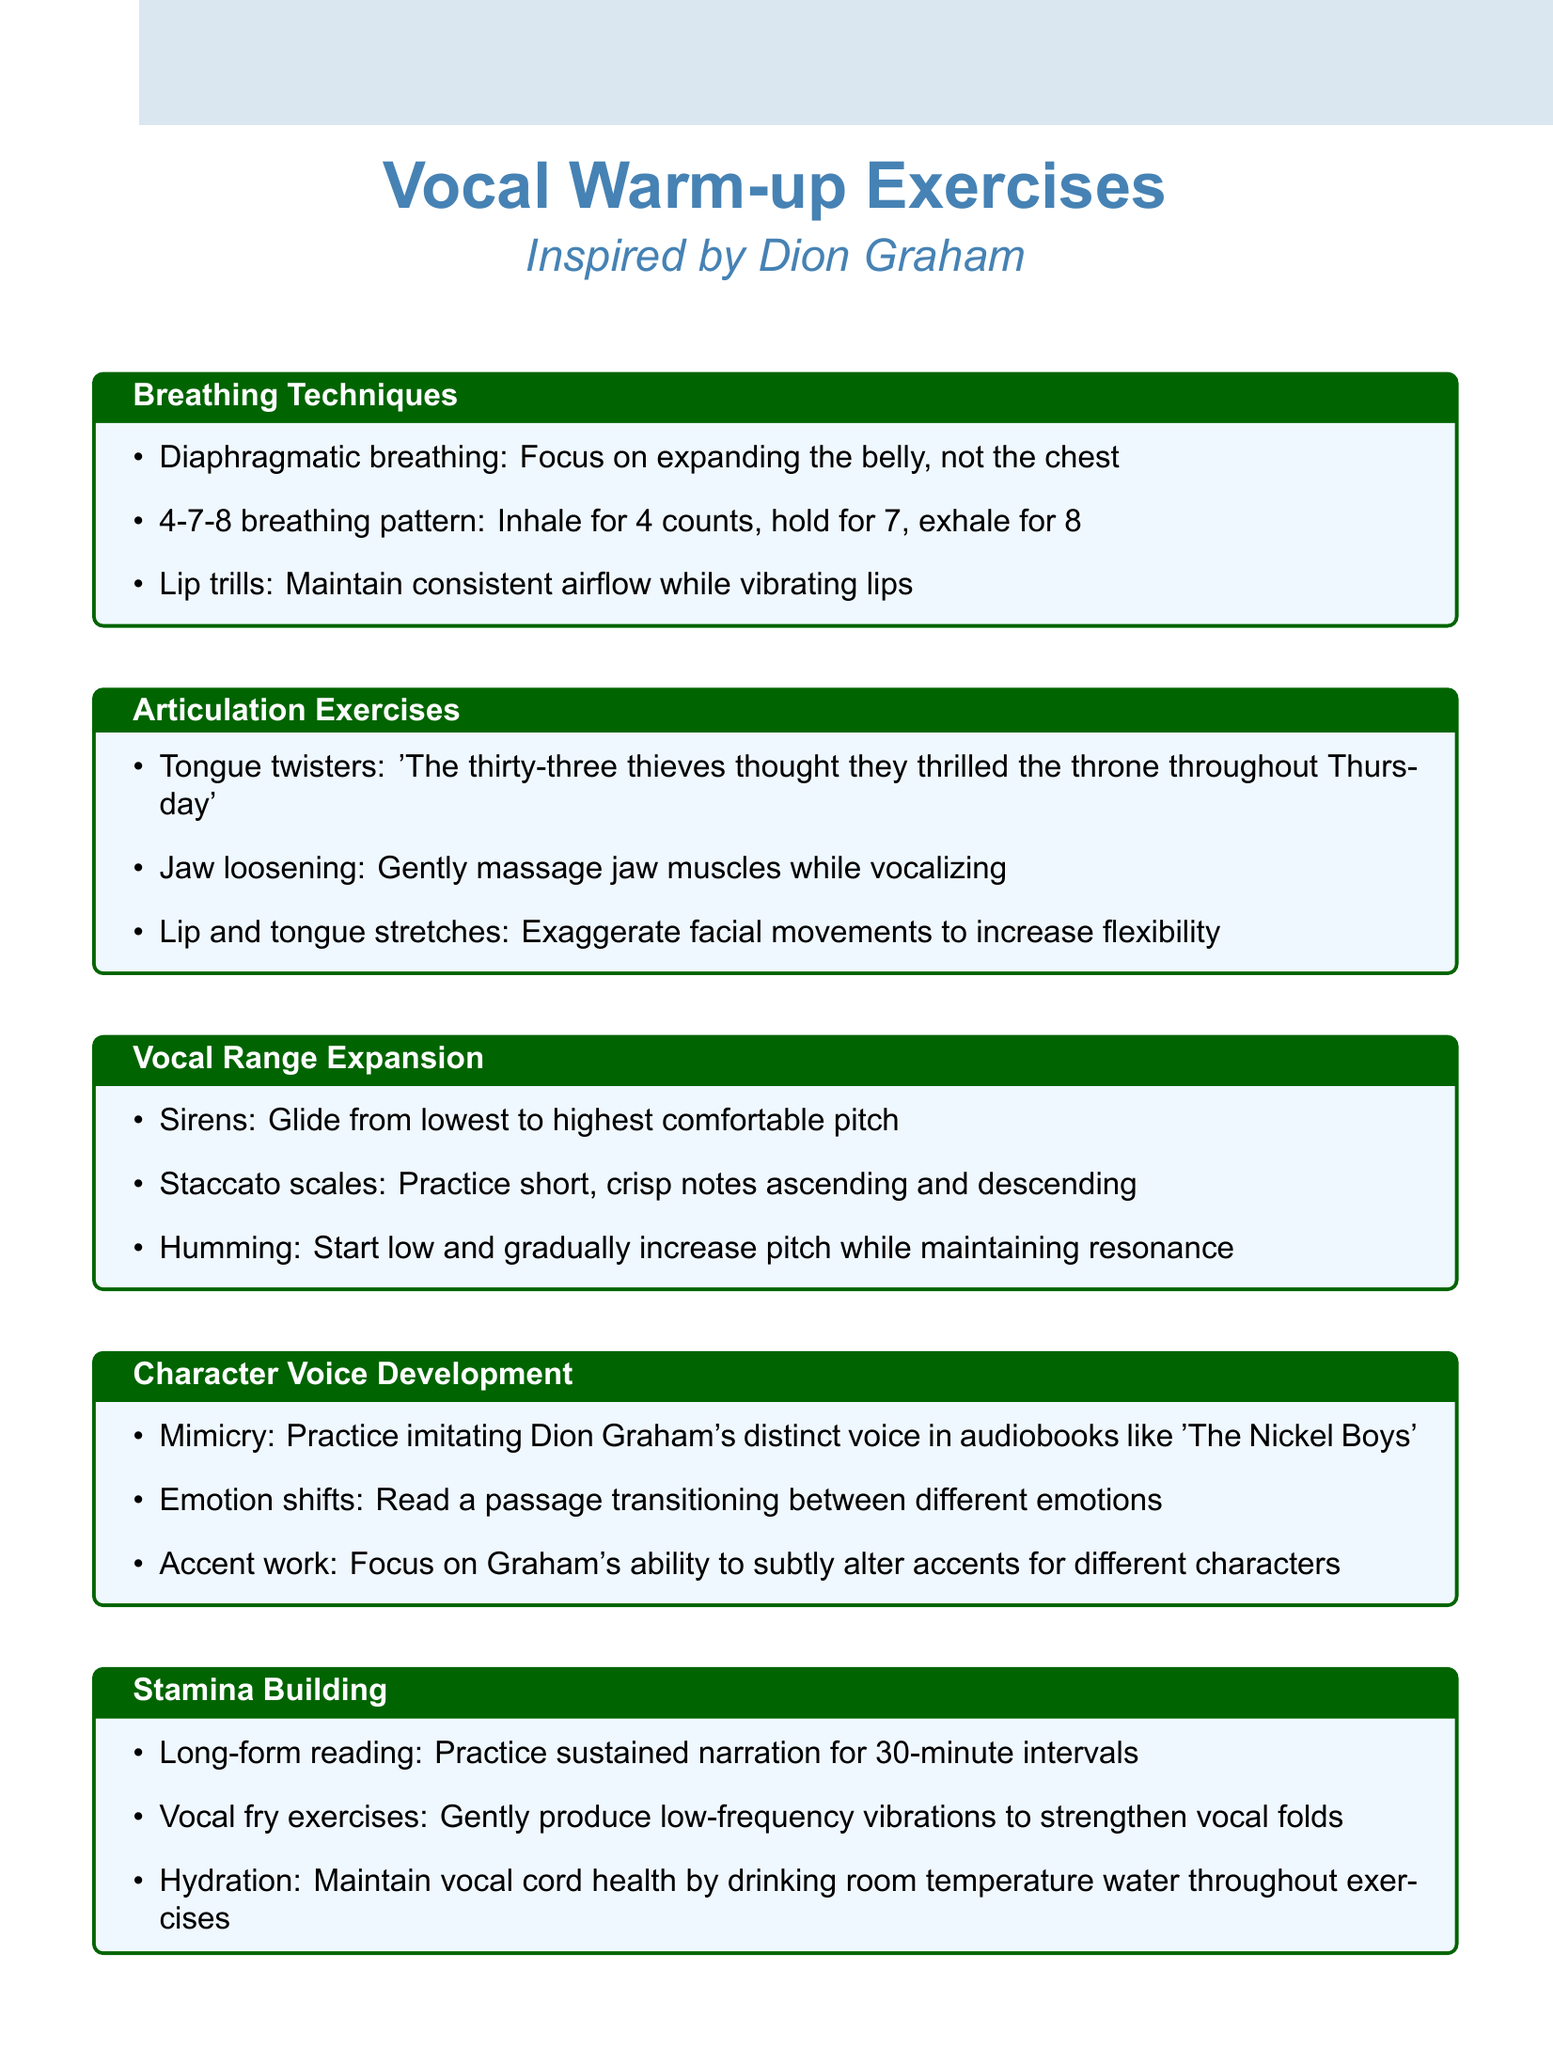What is the first breathing technique mentioned? The first breathing technique listed in the document is 'Diaphragmatic breathing'.
Answer: Diaphragmatic breathing How many counts are in the 4-7-8 breathing pattern? The 4-7-8 breathing pattern includes inhaling for 4 counts, holding for 7, and exhaling for 8.
Answer: 4 What is the purpose of lip trills? Lip trills are meant to maintain consistent airflow while vibrating the lips.
Answer: Maintain consistent airflow Name a vocal range expansion exercise. One of the exercises for vocal range expansion is 'Sirens'.
Answer: Sirens Which exercise helps with character voice development through imitation? The exercise for character voice development that involves imitation is 'Mimicry'.
Answer: Mimicry What hydration practice is recommended during vocal exercises? The document recommends maintaining vocal cord health by drinking room temperature water throughout exercises.
Answer: Drinking room temperature water How long should long-form reading be practiced for stamina building? Long-form reading should be practiced for 30-minute intervals according to the notes.
Answer: 30-minute intervals What type of exercises are tongue twisters? Tongue twisters fall under the category of articulation exercises in the document.
Answer: Articulation exercises 